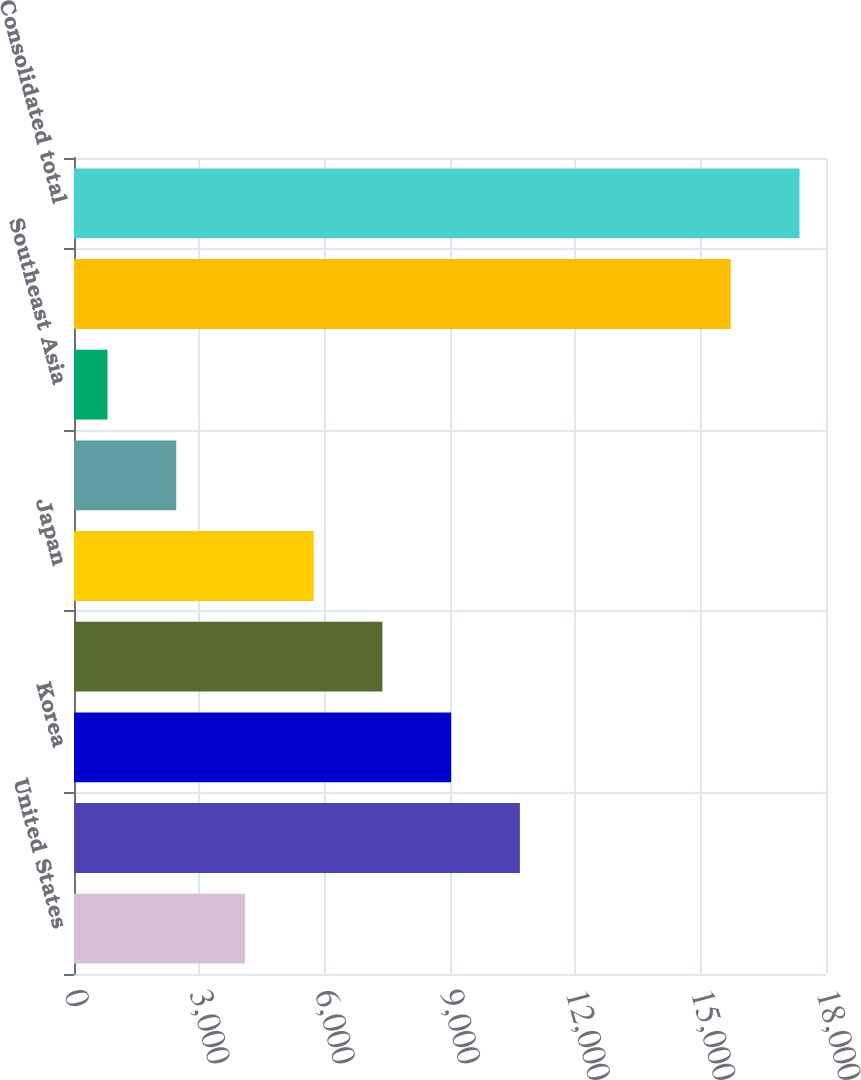<chart> <loc_0><loc_0><loc_500><loc_500><bar_chart><fcel>United States<fcel>China<fcel>Korea<fcel>Taiwan<fcel>Japan<fcel>Europe<fcel>Southeast Asia<fcel>Total outside United States<fcel>Consolidated total<nl><fcel>4092.2<fcel>10672.6<fcel>9027.5<fcel>7382.4<fcel>5737.3<fcel>2447.1<fcel>802<fcel>15721<fcel>17366.1<nl></chart> 